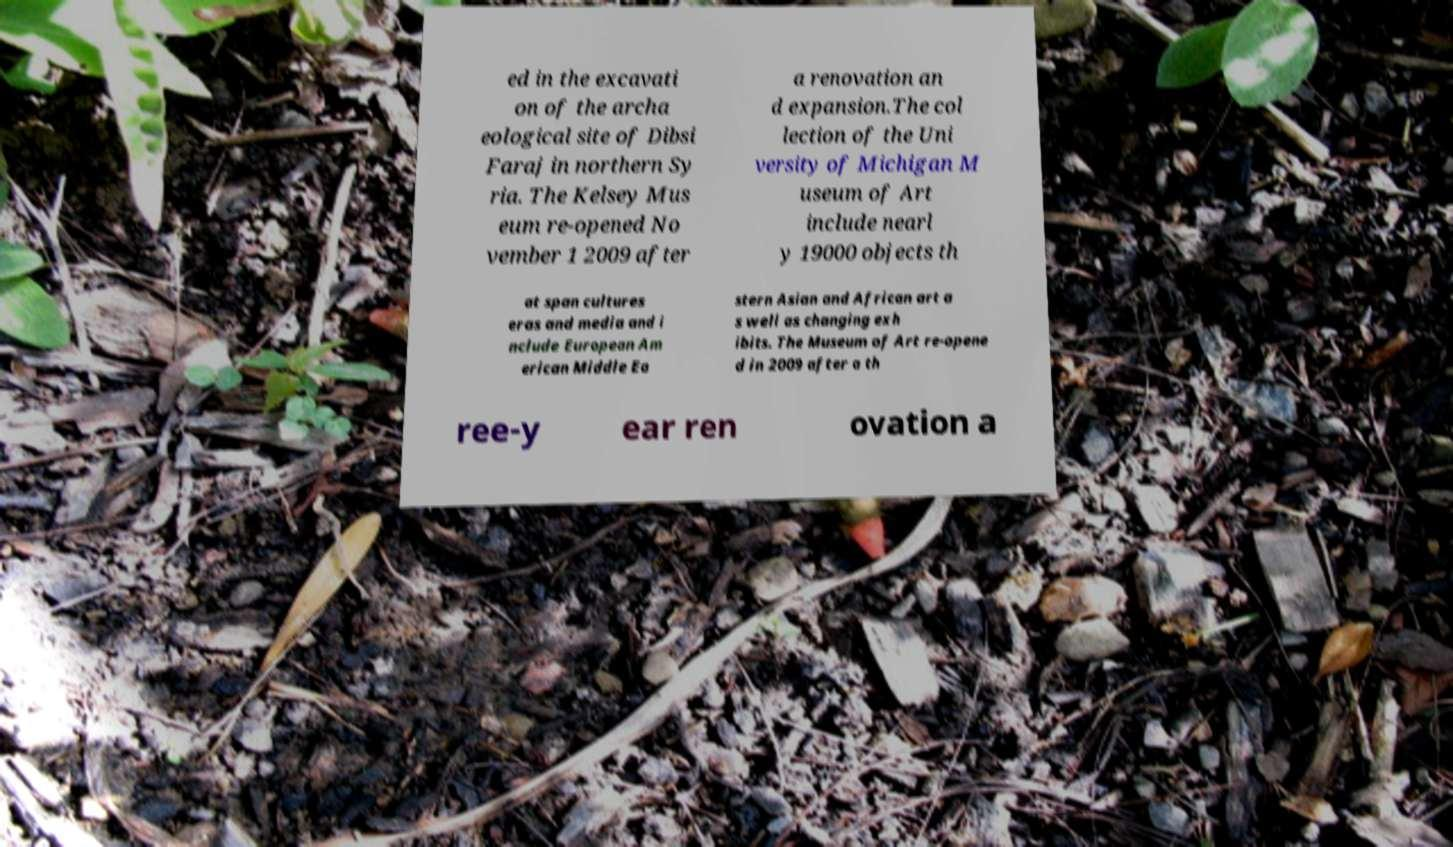I need the written content from this picture converted into text. Can you do that? ed in the excavati on of the archa eological site of Dibsi Faraj in northern Sy ria. The Kelsey Mus eum re-opened No vember 1 2009 after a renovation an d expansion.The col lection of the Uni versity of Michigan M useum of Art include nearl y 19000 objects th at span cultures eras and media and i nclude European Am erican Middle Ea stern Asian and African art a s well as changing exh ibits. The Museum of Art re-opene d in 2009 after a th ree-y ear ren ovation a 